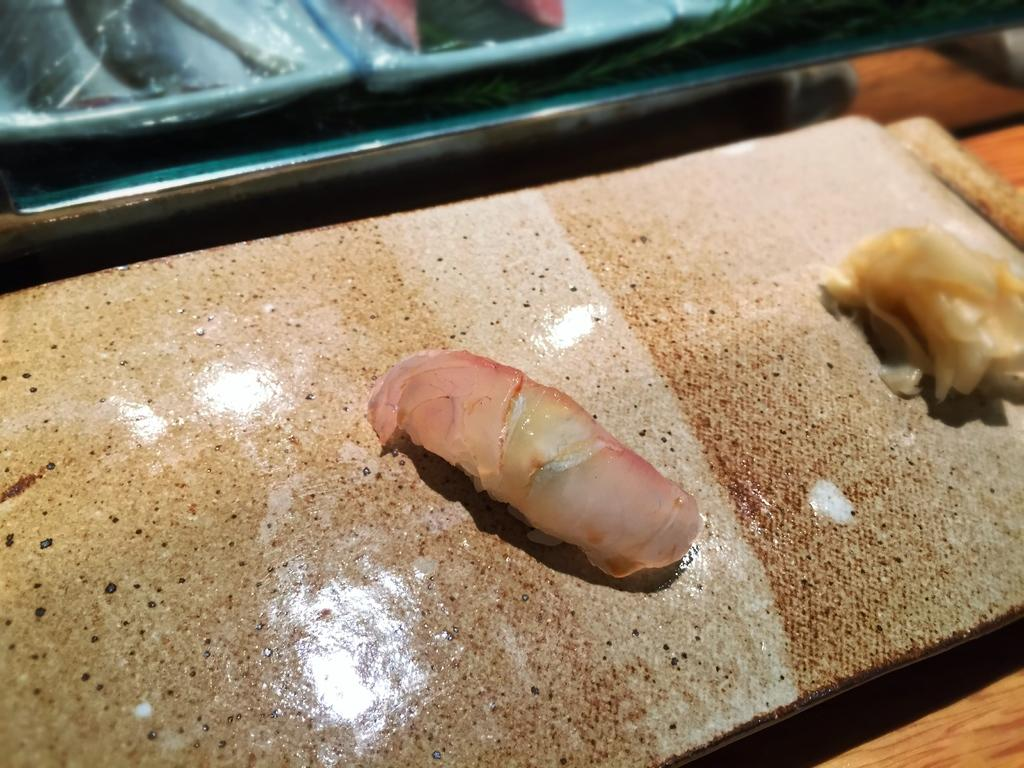What is on the wooden board in the image? There are two pieces of meat on a wooden board. Where is the wooden board located? The wooden board is on a platform. What is beside the wooden board? There is a plate beside the wooden board. Can you describe the contents of the plate? The plate contains an unspecified item. How many sticks are used to hold the meat in the image? There are no sticks visible in the image; the meat is placed directly on the wooden board. 